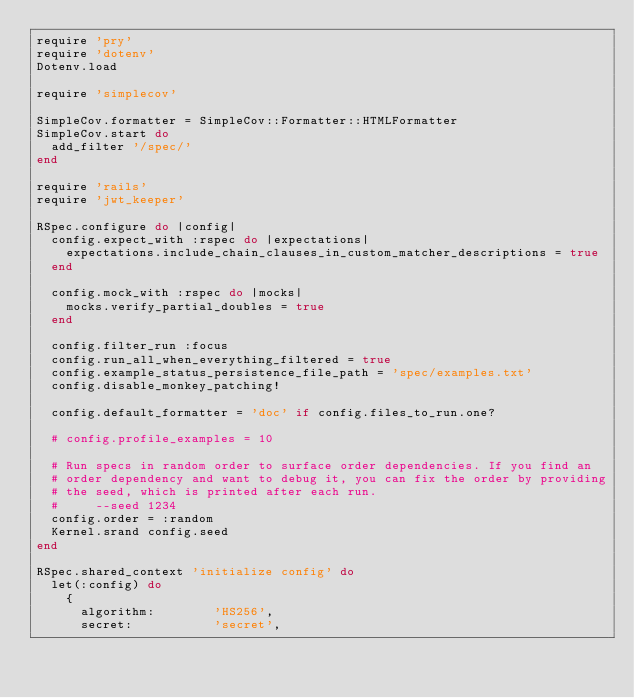Convert code to text. <code><loc_0><loc_0><loc_500><loc_500><_Ruby_>require 'pry'
require 'dotenv'
Dotenv.load

require 'simplecov'

SimpleCov.formatter = SimpleCov::Formatter::HTMLFormatter
SimpleCov.start do
  add_filter '/spec/'
end

require 'rails'
require 'jwt_keeper'

RSpec.configure do |config|
  config.expect_with :rspec do |expectations|
    expectations.include_chain_clauses_in_custom_matcher_descriptions = true
  end

  config.mock_with :rspec do |mocks|
    mocks.verify_partial_doubles = true
  end

  config.filter_run :focus
  config.run_all_when_everything_filtered = true
  config.example_status_persistence_file_path = 'spec/examples.txt'
  config.disable_monkey_patching!

  config.default_formatter = 'doc' if config.files_to_run.one?

  # config.profile_examples = 10

  # Run specs in random order to surface order dependencies. If you find an
  # order dependency and want to debug it, you can fix the order by providing
  # the seed, which is printed after each run.
  #     --seed 1234
  config.order = :random
  Kernel.srand config.seed
end

RSpec.shared_context 'initialize config' do
  let(:config) do
    {
      algorithm:        'HS256',
      secret:           'secret',</code> 